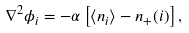<formula> <loc_0><loc_0><loc_500><loc_500>\nabla ^ { 2 } \phi _ { i } = - \alpha \left [ \langle n _ { i } \rangle - n _ { + } ( { i } ) \right ] ,</formula> 